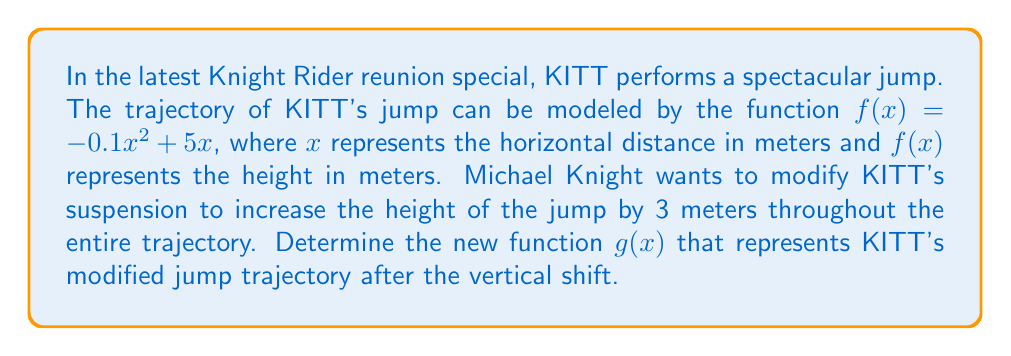Can you solve this math problem? To solve this problem, we need to apply the concept of vertical shifts in function transformations. Here's a step-by-step explanation:

1. The original function is $f(x) = -0.1x^2 + 5x$.

2. We want to shift the entire function upward by 3 meters. In function transformations, a vertical shift is achieved by adding or subtracting a constant to the function.

3. To shift a function vertically upward by $k$ units, we add $k$ to the function. In this case, $k = 3$.

4. The general form of a vertical shift is:
   $g(x) = f(x) + k$ for an upward shift
   $g(x) = f(x) - k$ for a downward shift

5. Applying this to our specific function:
   $g(x) = f(x) + 3$
   $g(x) = (-0.1x^2 + 5x) + 3$

6. Simplifying:
   $g(x) = -0.1x^2 + 5x + 3$

This new function $g(x)$ represents KITT's trajectory after the suspension modification, shifted 3 meters higher than the original jump.
Answer: $g(x) = -0.1x^2 + 5x + 3$ 